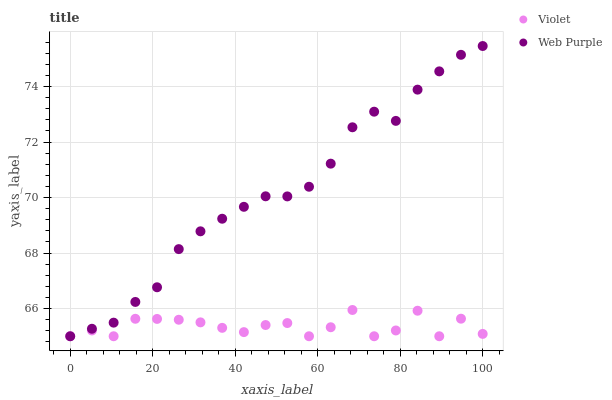Does Violet have the minimum area under the curve?
Answer yes or no. Yes. Does Web Purple have the maximum area under the curve?
Answer yes or no. Yes. Does Violet have the maximum area under the curve?
Answer yes or no. No. Is Web Purple the smoothest?
Answer yes or no. Yes. Is Violet the roughest?
Answer yes or no. Yes. Is Violet the smoothest?
Answer yes or no. No. Does Web Purple have the lowest value?
Answer yes or no. Yes. Does Web Purple have the highest value?
Answer yes or no. Yes. Does Violet have the highest value?
Answer yes or no. No. Does Web Purple intersect Violet?
Answer yes or no. Yes. Is Web Purple less than Violet?
Answer yes or no. No. Is Web Purple greater than Violet?
Answer yes or no. No. 